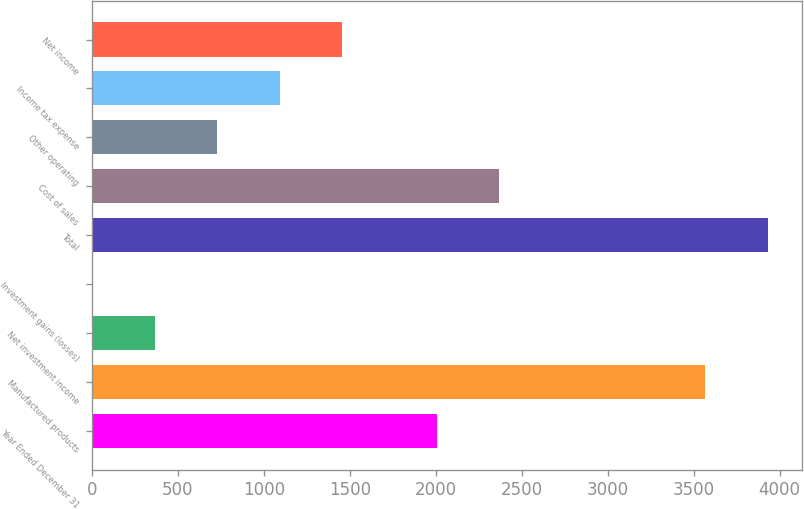<chart> <loc_0><loc_0><loc_500><loc_500><bar_chart><fcel>Year Ended December 31<fcel>Manufactured products<fcel>Net investment income<fcel>Investment gains (losses)<fcel>Total<fcel>Cost of sales<fcel>Other operating<fcel>Income tax expense<fcel>Net income<nl><fcel>2005<fcel>3567.8<fcel>365.42<fcel>2.1<fcel>3931.12<fcel>2368.32<fcel>728.74<fcel>1092.06<fcel>1455.38<nl></chart> 